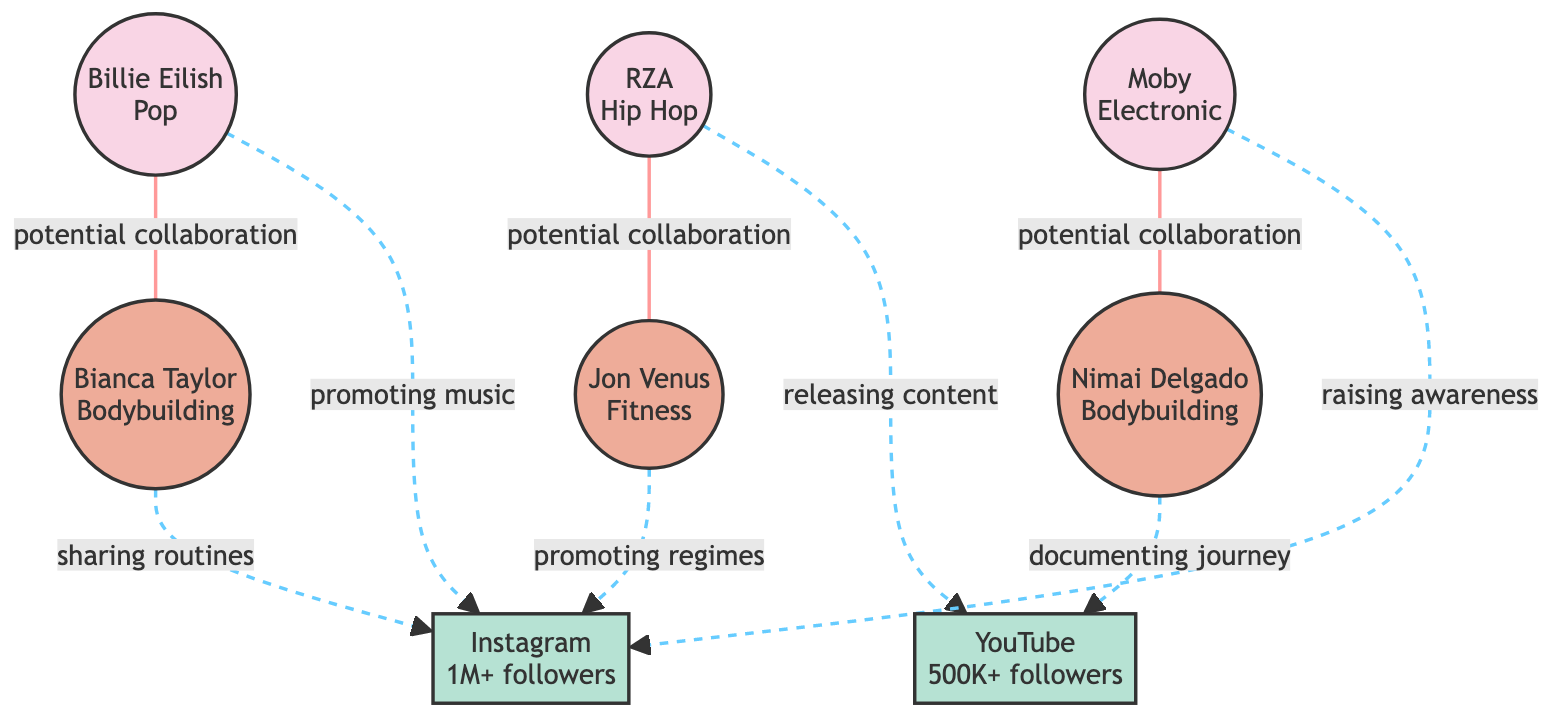What types of nodes are present in the diagram? The diagram contains three types of nodes: musicians, fitness influencers, and platforms. This can be identified by their distinct labels and characteristics.
Answer: musician, fitness influencer, platform How many vegan musicians are there? The diagram lists three vegan musicians: Billie Eilish, RZA, and Moby. We can count the nodes with the type "musician" that have the vegan attribute set to true.
Answer: 3 Which musician has a potential collaboration with Nimai Delgado? The diagram indicates that Moby has a potential collaboration with Nimai Delgado by showing a link between the two nodes, which is labeled "potential collaboration."
Answer: Moby What is the primary platform used by Bianca Taylor? The diagram shows that Bianca Taylor uses Instagram for sharing bodybuilding routines, as indicated by the connection labeled "platform used."
Answer: Instagram What is the shared interest between RZA and Jon Venus? The diagram states that RZA and Jon Venus have a shared interest in veganism and fitness, highlighted in the link labeled "potential collaboration."
Answer: veganism, fitness Which platform has the most followers? The diagram shows that Instagram has 1M+ followers, while YouTube has 500K+. By comparing the follower counts, we can see that Instagram has more followers.
Answer: Instagram Which musician promotes vegan music on Instagram? The diagram indicates that Billie Eilish promotes vegan music specifically on Instagram, as shown by the connection labeled "platform used."
Answer: Billie Eilish How many potential collaborations are indicated in the diagram? By examining the links labeled "potential collaboration," we find three connections (Billie Eilish to Bianca Taylor, RZA to Jon Venus, Moby to Nimai Delgado). Therefore, there are three potential collaborations.
Answer: 3 What is Nimai Delgado's focus in fitness? The diagram shows that Nimai Delgado's focus is Bodybuilding, as detailed in the node labeled with his name.
Answer: Bodybuilding 